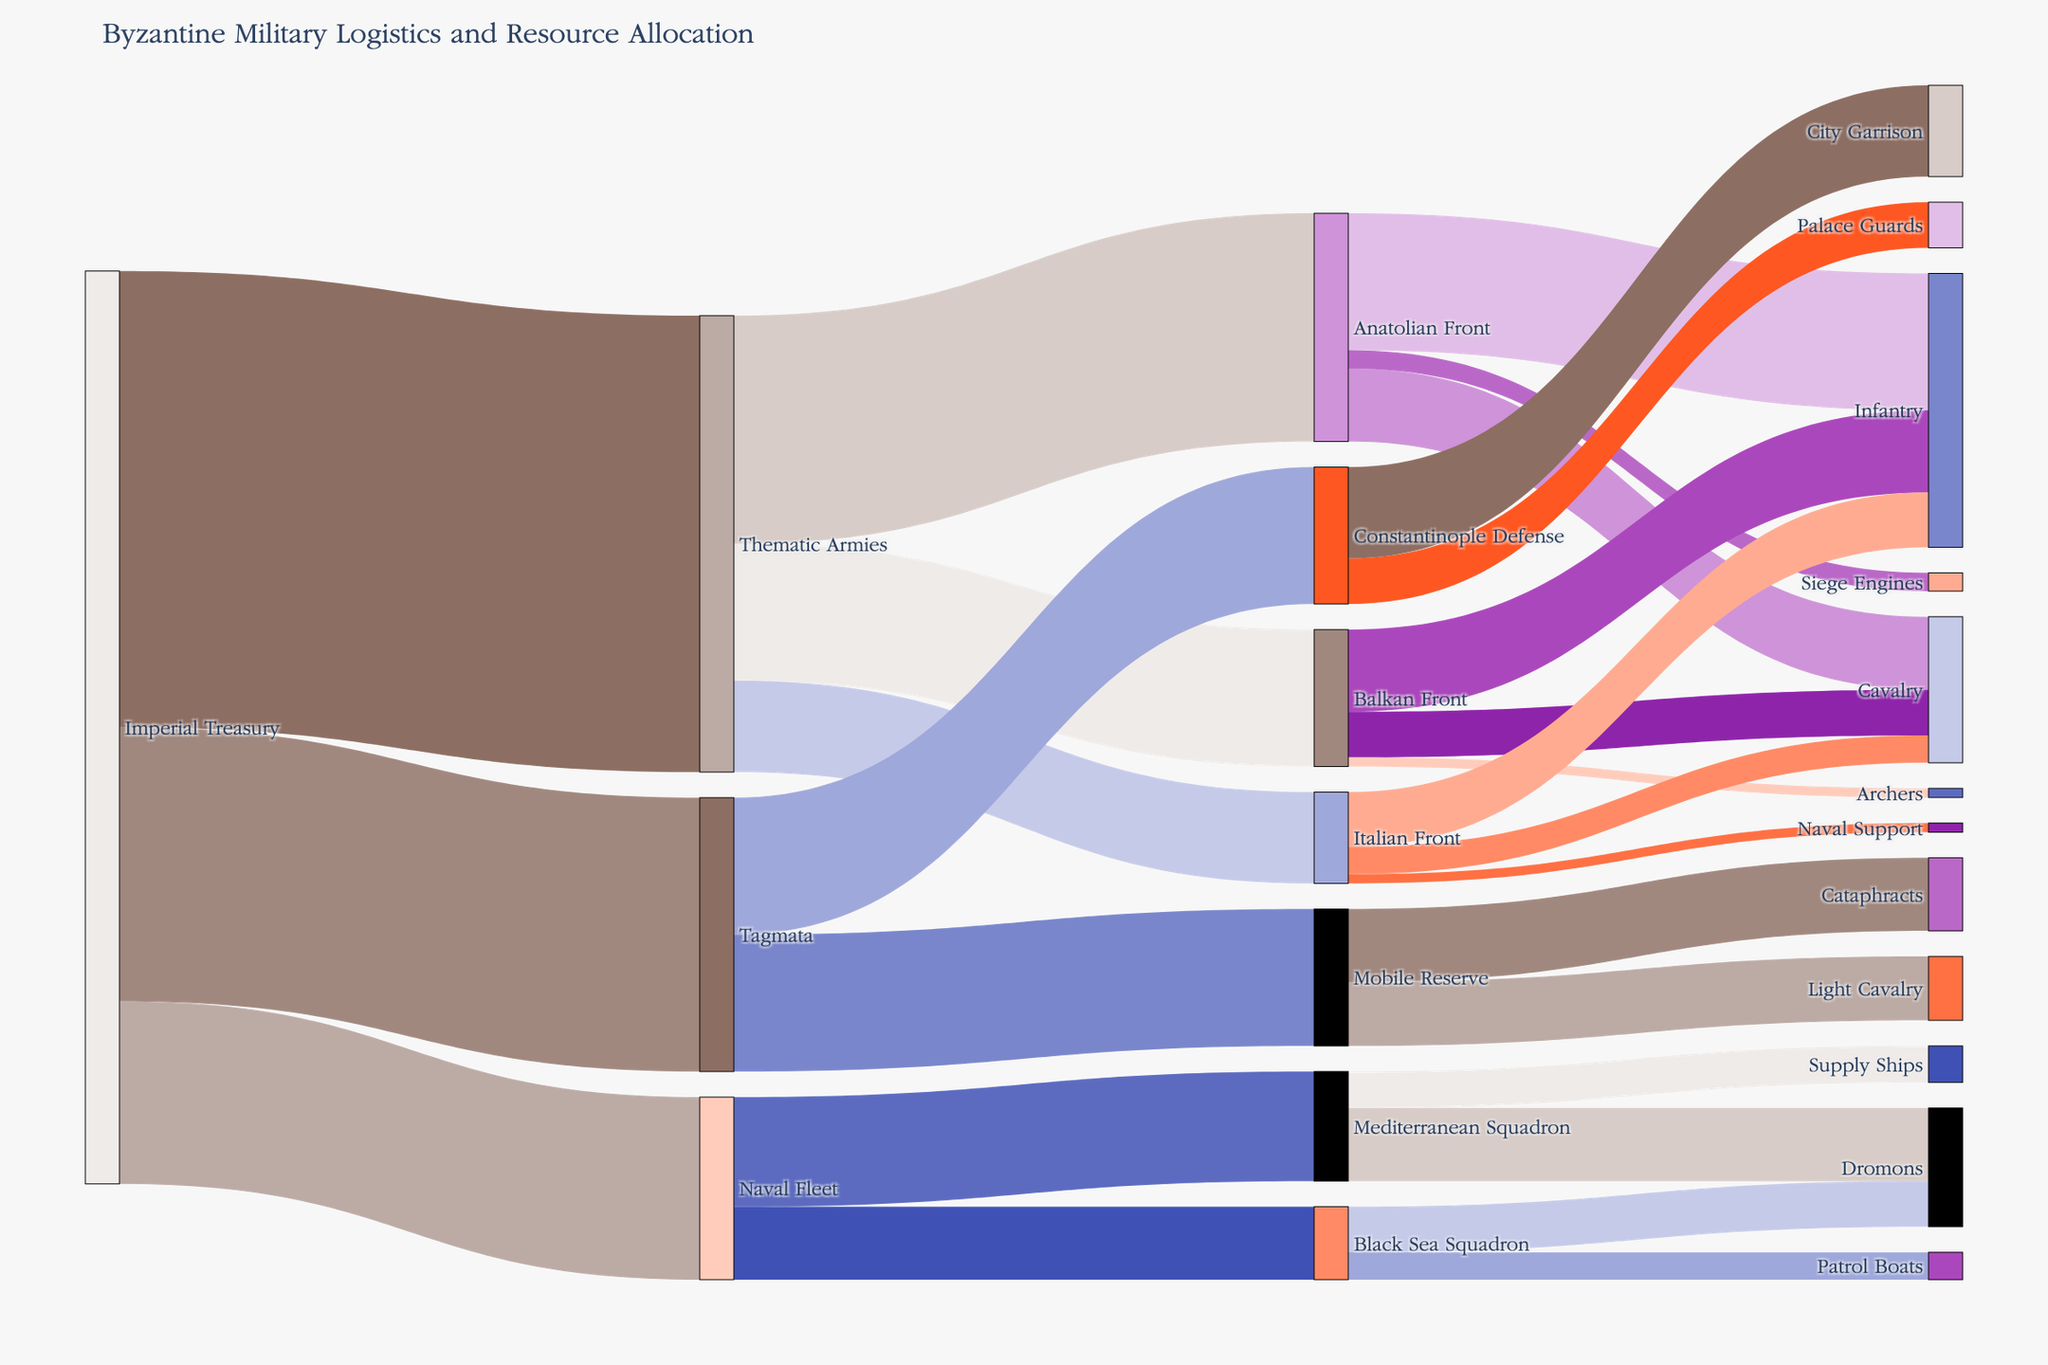What is the total resource allocation from the Imperial Treasury? To find the total resource allocation from the Imperial Treasury, sum the values directed to Thematic Armies, Tagmata, and Naval Fleet. This is 5000 + 3000 + 2000 = 10000
Answer: 10000 Which military front receives the most resources from the Thematic Armies? By looking at the values connected from Thematic Armies to each front, we see Anatolian Front receives 2500, Balkan Front receives 1500, and Italian Front receives 1000. Thus, Anatolian Front receives the most resources.
Answer: Anatolian Front How do the resources allocated to the Constantinople Defense and the Mobile Reserve compare? The resources allocated to the Constantinople Defense are 1500, while the Mobile Reserve also receives 1500.
Answer: They are equal Which naval squadron receives more resources, the Mediterranean Squadron or the Black Sea Squadron? To compare, we observe the values directed towards each squadron. The Mediterranean Squadron receives 1200, and the Black Sea Squadron receives 800. Therefore, the Mediterranean Squadron receives more resources.
Answer: Mediterranean Squadron What is the total number of infantry across all fronts? Sum the infantry resources across the Anatolian Front (1500), Balkan Front (900), and Italian Front (600). This totals to 1500 + 900 + 600 = 3000
Answer: 3000 How much resource is allocated to Siege Engines on the Anatolian Front? The value directed towards Siege Engines from the Anatolian Front is explicitly shown as 200
Answer: 200 What is the difference in the resources allocated to the Palace Guards and the City Garrison within Constantinople Defense? The resources for Palace Guards are 500, and for City Garrison they are 1000. The difference is 1000 - 500 = 500
Answer: 500 Compare the resources allocated to Dromons in the Mediterranean Squadron and the Black Sea Squadron. Which has more and by how much? The Mediterranean Squadron allocates 800 to Dromons, while the Black Sea Squadron allocates 500. The difference is 800 - 500 = 300, indicating the Mediterranean Squadron allocates 300 more.
Answer: Mediterranean Squadron by 300 How many different nodes are there in the Sankey Diagram? Count the unique node names listed in the diagram. This includes Imperial Treasury, Thematic Armies, Tagmata, etc., totaling 19 nodes.
Answer: 19 What are the specific types of divisions within the Mobile Reserve? The nodes under Mobile Reserve are Cataphracts (800) and Light Cavalry (700).
Answer: Cataphracts and Light Cavalry 